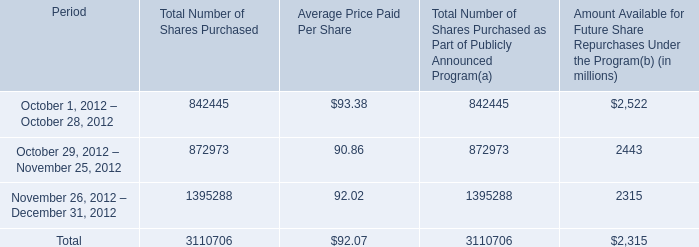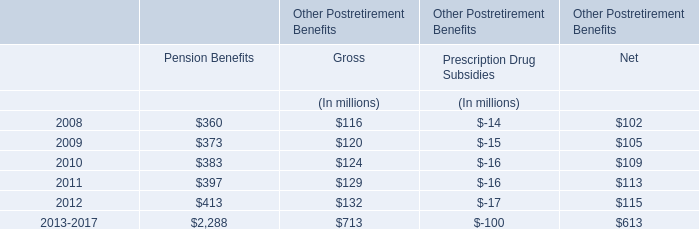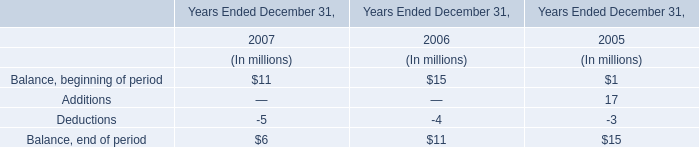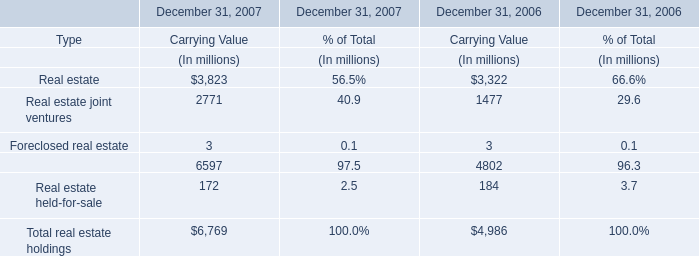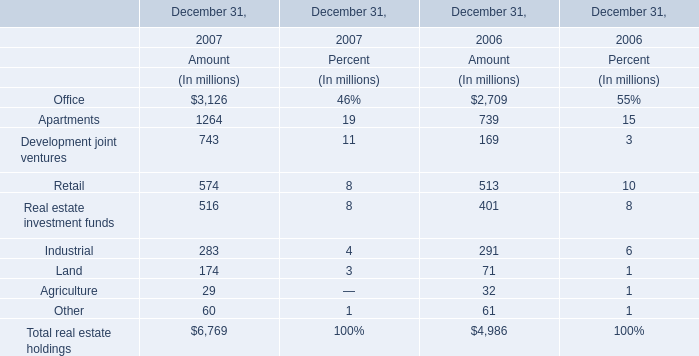What is the sum of the Real estate investment funds in the years where Development joint ventures is positive? (in million) 
Computations: (516 + 401)
Answer: 917.0. 